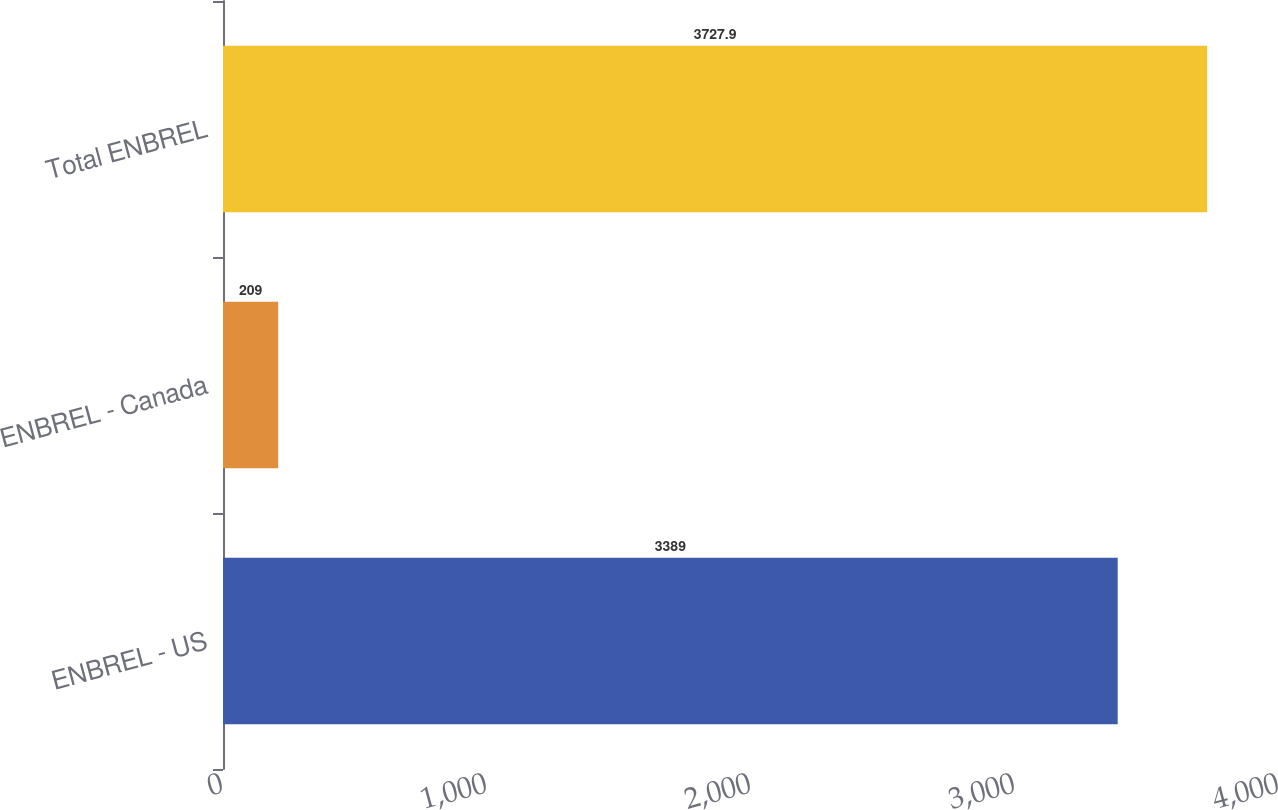Convert chart to OTSL. <chart><loc_0><loc_0><loc_500><loc_500><bar_chart><fcel>ENBREL - US<fcel>ENBREL - Canada<fcel>Total ENBREL<nl><fcel>3389<fcel>209<fcel>3727.9<nl></chart> 